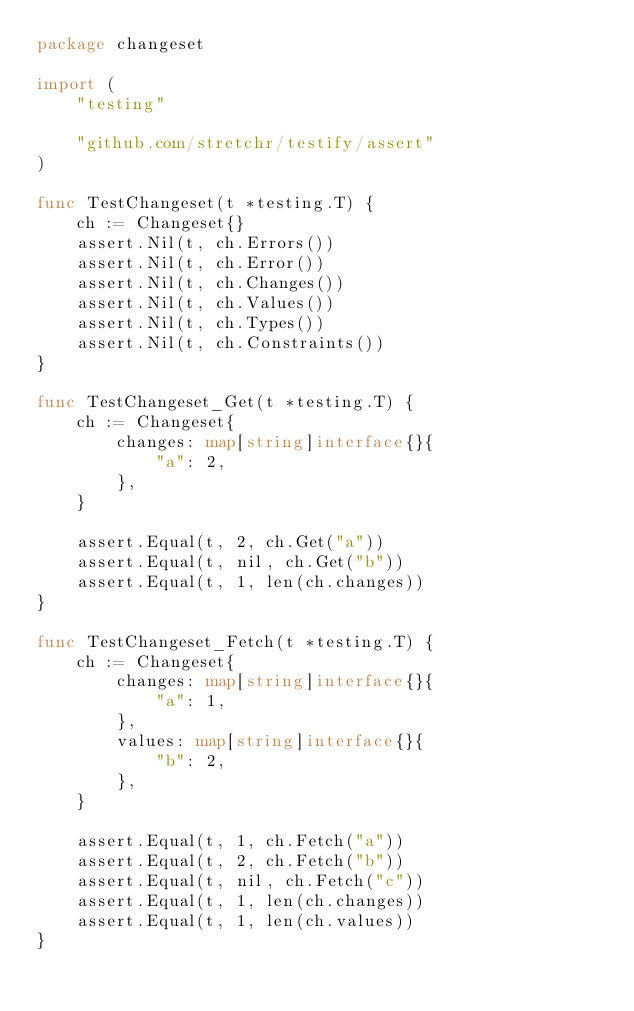<code> <loc_0><loc_0><loc_500><loc_500><_Go_>package changeset

import (
	"testing"

	"github.com/stretchr/testify/assert"
)

func TestChangeset(t *testing.T) {
	ch := Changeset{}
	assert.Nil(t, ch.Errors())
	assert.Nil(t, ch.Error())
	assert.Nil(t, ch.Changes())
	assert.Nil(t, ch.Values())
	assert.Nil(t, ch.Types())
	assert.Nil(t, ch.Constraints())
}

func TestChangeset_Get(t *testing.T) {
	ch := Changeset{
		changes: map[string]interface{}{
			"a": 2,
		},
	}

	assert.Equal(t, 2, ch.Get("a"))
	assert.Equal(t, nil, ch.Get("b"))
	assert.Equal(t, 1, len(ch.changes))
}

func TestChangeset_Fetch(t *testing.T) {
	ch := Changeset{
		changes: map[string]interface{}{
			"a": 1,
		},
		values: map[string]interface{}{
			"b": 2,
		},
	}

	assert.Equal(t, 1, ch.Fetch("a"))
	assert.Equal(t, 2, ch.Fetch("b"))
	assert.Equal(t, nil, ch.Fetch("c"))
	assert.Equal(t, 1, len(ch.changes))
	assert.Equal(t, 1, len(ch.values))
}
</code> 